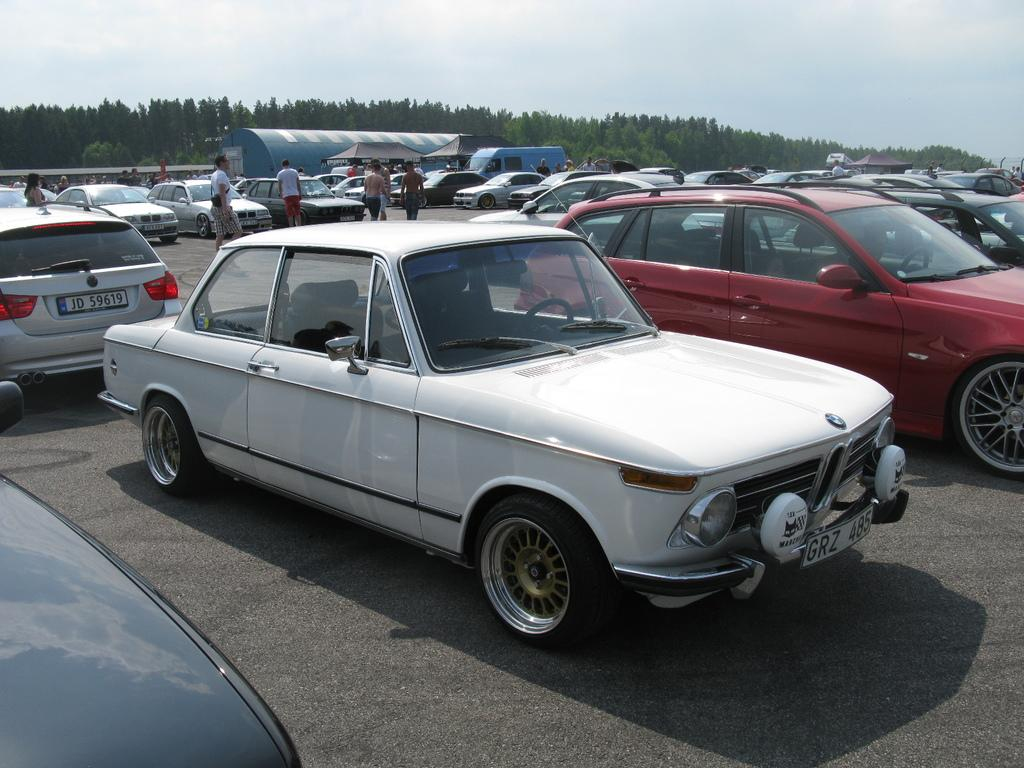What can be seen parked in the image? There are vehicles parked in the image. What are the people in the image doing? There are people walking around in the image. What structure is visible in the background of the image? There is a shed visible in the background of the image. What type of natural scenery is present in the background of the image? There are trees present in the background of the image. What word is being used by the authority in the image? There is no authority figure or spoken word present in the image. What type of cutting tool is being used by the people in the image? There is no cutting tool, such as scissors, present in the image. 